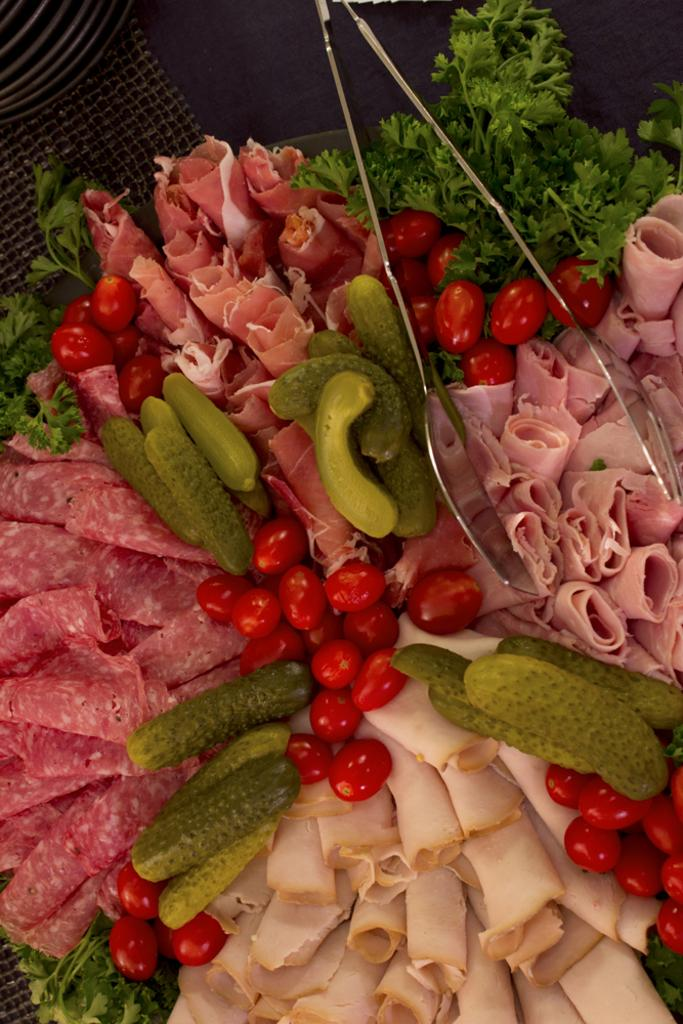What is present on the plate in the image? There are food items on the plate in the image. What objects are visible in the image besides the plate? Tongs are visible in the image. How many apples can be seen floating in the waves in the image? There are no apples or waves present in the image. 